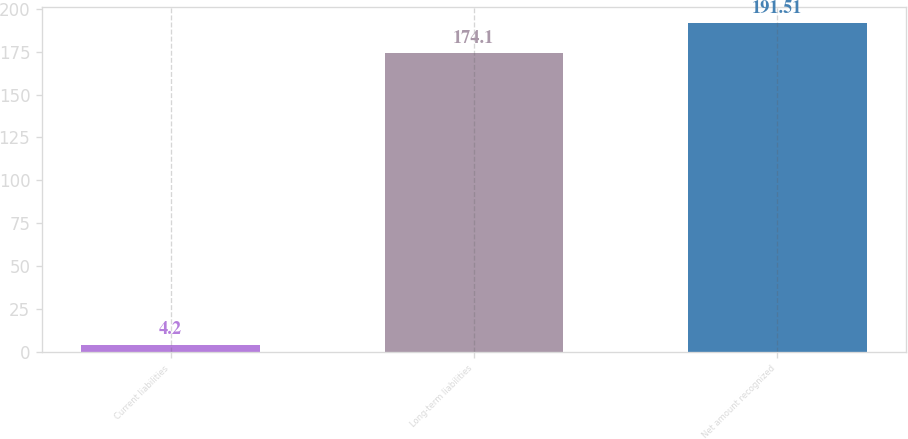Convert chart to OTSL. <chart><loc_0><loc_0><loc_500><loc_500><bar_chart><fcel>Current liabilities<fcel>Long-term liabilities<fcel>Net amount recognized<nl><fcel>4.2<fcel>174.1<fcel>191.51<nl></chart> 